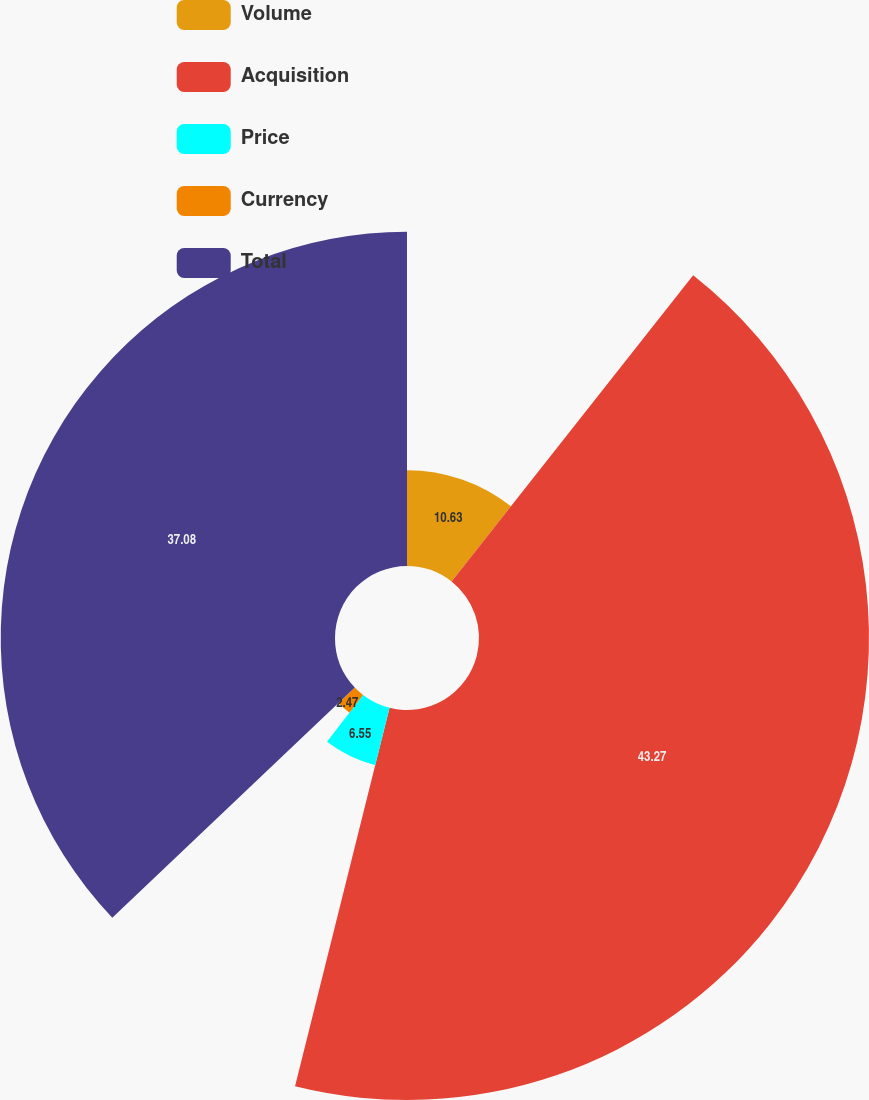Convert chart. <chart><loc_0><loc_0><loc_500><loc_500><pie_chart><fcel>Volume<fcel>Acquisition<fcel>Price<fcel>Currency<fcel>Total<nl><fcel>10.63%<fcel>43.26%<fcel>6.55%<fcel>2.47%<fcel>37.08%<nl></chart> 